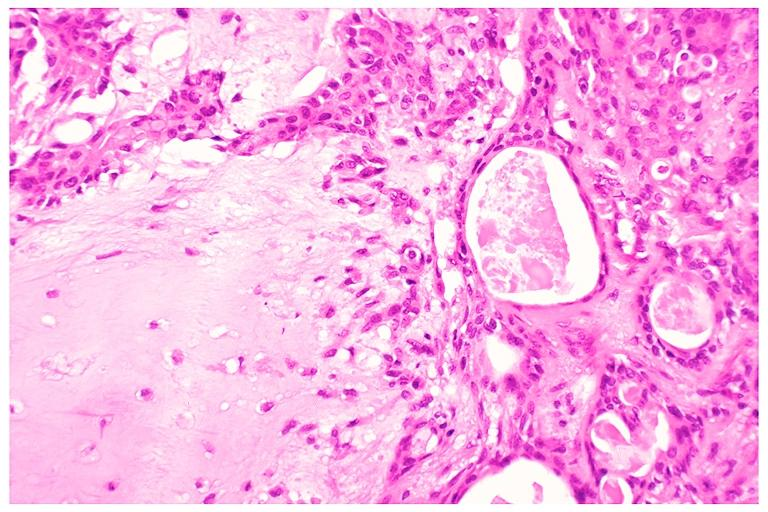does this image show pleomorphic adenoma benign mixed tumor?
Answer the question using a single word or phrase. Yes 